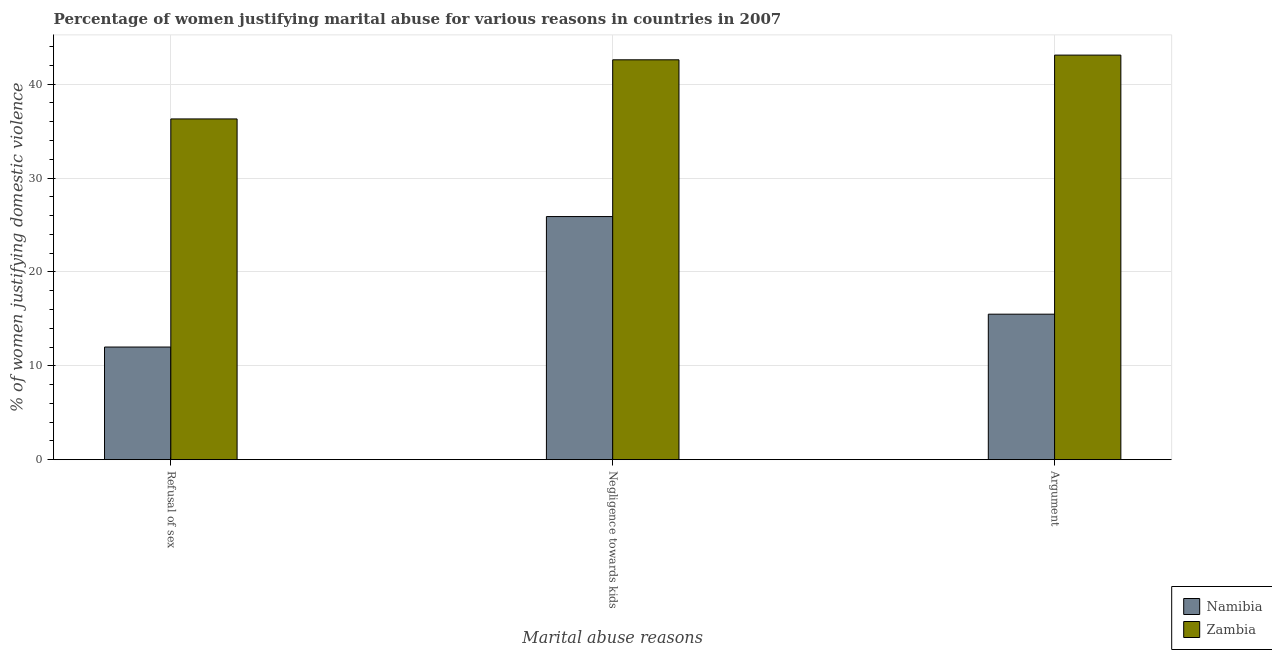How many groups of bars are there?
Keep it short and to the point. 3. Are the number of bars on each tick of the X-axis equal?
Give a very brief answer. Yes. What is the label of the 3rd group of bars from the left?
Offer a terse response. Argument. What is the percentage of women justifying domestic violence due to refusal of sex in Zambia?
Provide a succinct answer. 36.3. Across all countries, what is the maximum percentage of women justifying domestic violence due to negligence towards kids?
Keep it short and to the point. 42.6. Across all countries, what is the minimum percentage of women justifying domestic violence due to negligence towards kids?
Provide a short and direct response. 25.9. In which country was the percentage of women justifying domestic violence due to negligence towards kids maximum?
Offer a terse response. Zambia. In which country was the percentage of women justifying domestic violence due to negligence towards kids minimum?
Provide a succinct answer. Namibia. What is the total percentage of women justifying domestic violence due to negligence towards kids in the graph?
Make the answer very short. 68.5. What is the difference between the percentage of women justifying domestic violence due to arguments in Namibia and that in Zambia?
Provide a short and direct response. -27.6. What is the difference between the percentage of women justifying domestic violence due to arguments in Zambia and the percentage of women justifying domestic violence due to negligence towards kids in Namibia?
Offer a terse response. 17.2. What is the average percentage of women justifying domestic violence due to refusal of sex per country?
Make the answer very short. 24.15. What is the difference between the percentage of women justifying domestic violence due to negligence towards kids and percentage of women justifying domestic violence due to refusal of sex in Namibia?
Your answer should be very brief. 13.9. In how many countries, is the percentage of women justifying domestic violence due to negligence towards kids greater than 38 %?
Your answer should be very brief. 1. What is the ratio of the percentage of women justifying domestic violence due to refusal of sex in Zambia to that in Namibia?
Your answer should be compact. 3.02. What is the difference between the highest and the second highest percentage of women justifying domestic violence due to refusal of sex?
Your response must be concise. 24.3. What is the difference between the highest and the lowest percentage of women justifying domestic violence due to negligence towards kids?
Provide a succinct answer. 16.7. In how many countries, is the percentage of women justifying domestic violence due to arguments greater than the average percentage of women justifying domestic violence due to arguments taken over all countries?
Your response must be concise. 1. Is the sum of the percentage of women justifying domestic violence due to negligence towards kids in Zambia and Namibia greater than the maximum percentage of women justifying domestic violence due to refusal of sex across all countries?
Your answer should be very brief. Yes. What does the 2nd bar from the left in Refusal of sex represents?
Make the answer very short. Zambia. What does the 1st bar from the right in Negligence towards kids represents?
Your answer should be compact. Zambia. Is it the case that in every country, the sum of the percentage of women justifying domestic violence due to refusal of sex and percentage of women justifying domestic violence due to negligence towards kids is greater than the percentage of women justifying domestic violence due to arguments?
Ensure brevity in your answer.  Yes. Does the graph contain any zero values?
Offer a terse response. No. Where does the legend appear in the graph?
Make the answer very short. Bottom right. What is the title of the graph?
Ensure brevity in your answer.  Percentage of women justifying marital abuse for various reasons in countries in 2007. What is the label or title of the X-axis?
Provide a succinct answer. Marital abuse reasons. What is the label or title of the Y-axis?
Give a very brief answer. % of women justifying domestic violence. What is the % of women justifying domestic violence of Zambia in Refusal of sex?
Ensure brevity in your answer.  36.3. What is the % of women justifying domestic violence of Namibia in Negligence towards kids?
Your answer should be compact. 25.9. What is the % of women justifying domestic violence of Zambia in Negligence towards kids?
Your response must be concise. 42.6. What is the % of women justifying domestic violence in Namibia in Argument?
Offer a terse response. 15.5. What is the % of women justifying domestic violence of Zambia in Argument?
Your response must be concise. 43.1. Across all Marital abuse reasons, what is the maximum % of women justifying domestic violence in Namibia?
Your answer should be compact. 25.9. Across all Marital abuse reasons, what is the maximum % of women justifying domestic violence of Zambia?
Keep it short and to the point. 43.1. Across all Marital abuse reasons, what is the minimum % of women justifying domestic violence of Namibia?
Ensure brevity in your answer.  12. Across all Marital abuse reasons, what is the minimum % of women justifying domestic violence in Zambia?
Provide a succinct answer. 36.3. What is the total % of women justifying domestic violence of Namibia in the graph?
Offer a very short reply. 53.4. What is the total % of women justifying domestic violence in Zambia in the graph?
Provide a short and direct response. 122. What is the difference between the % of women justifying domestic violence of Zambia in Refusal of sex and that in Negligence towards kids?
Provide a short and direct response. -6.3. What is the difference between the % of women justifying domestic violence in Namibia in Refusal of sex and that in Argument?
Your answer should be compact. -3.5. What is the difference between the % of women justifying domestic violence in Namibia in Negligence towards kids and that in Argument?
Keep it short and to the point. 10.4. What is the difference between the % of women justifying domestic violence in Zambia in Negligence towards kids and that in Argument?
Give a very brief answer. -0.5. What is the difference between the % of women justifying domestic violence of Namibia in Refusal of sex and the % of women justifying domestic violence of Zambia in Negligence towards kids?
Offer a very short reply. -30.6. What is the difference between the % of women justifying domestic violence in Namibia in Refusal of sex and the % of women justifying domestic violence in Zambia in Argument?
Provide a short and direct response. -31.1. What is the difference between the % of women justifying domestic violence of Namibia in Negligence towards kids and the % of women justifying domestic violence of Zambia in Argument?
Offer a terse response. -17.2. What is the average % of women justifying domestic violence in Zambia per Marital abuse reasons?
Keep it short and to the point. 40.67. What is the difference between the % of women justifying domestic violence of Namibia and % of women justifying domestic violence of Zambia in Refusal of sex?
Keep it short and to the point. -24.3. What is the difference between the % of women justifying domestic violence of Namibia and % of women justifying domestic violence of Zambia in Negligence towards kids?
Ensure brevity in your answer.  -16.7. What is the difference between the % of women justifying domestic violence of Namibia and % of women justifying domestic violence of Zambia in Argument?
Give a very brief answer. -27.6. What is the ratio of the % of women justifying domestic violence in Namibia in Refusal of sex to that in Negligence towards kids?
Provide a short and direct response. 0.46. What is the ratio of the % of women justifying domestic violence of Zambia in Refusal of sex to that in Negligence towards kids?
Your answer should be very brief. 0.85. What is the ratio of the % of women justifying domestic violence of Namibia in Refusal of sex to that in Argument?
Ensure brevity in your answer.  0.77. What is the ratio of the % of women justifying domestic violence in Zambia in Refusal of sex to that in Argument?
Provide a short and direct response. 0.84. What is the ratio of the % of women justifying domestic violence of Namibia in Negligence towards kids to that in Argument?
Offer a very short reply. 1.67. What is the ratio of the % of women justifying domestic violence in Zambia in Negligence towards kids to that in Argument?
Your response must be concise. 0.99. What is the difference between the highest and the lowest % of women justifying domestic violence of Namibia?
Make the answer very short. 13.9. 